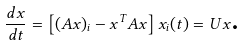<formula> <loc_0><loc_0><loc_500><loc_500>\frac { d x } { d t } = \left [ ( A x ) _ { i } - x ^ { T } A x \right ] x _ { i } ( t ) = U x \text {.}</formula> 